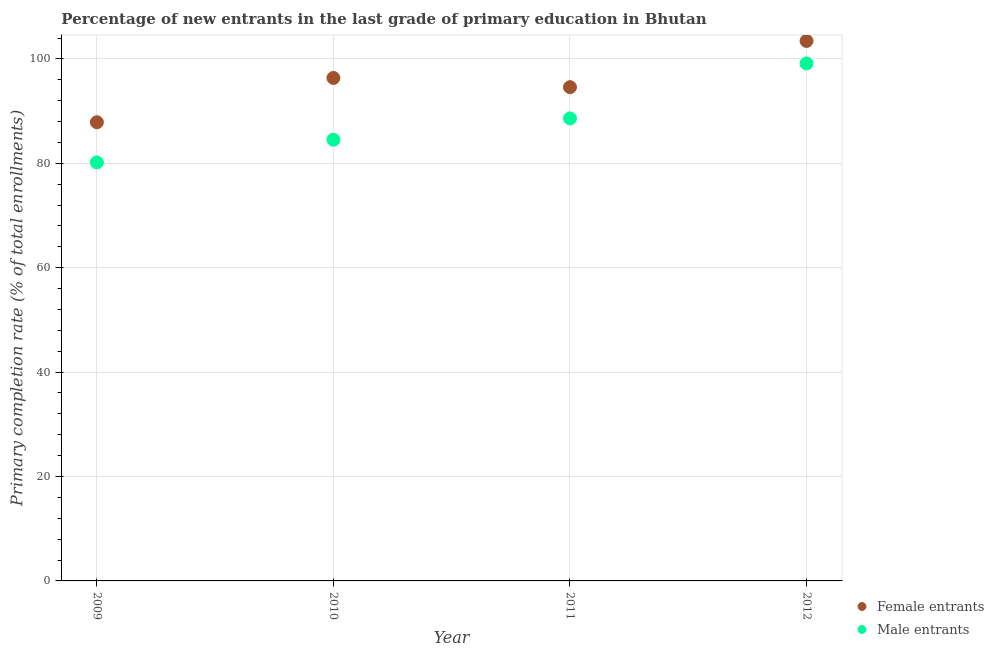How many different coloured dotlines are there?
Your response must be concise. 2. What is the primary completion rate of female entrants in 2010?
Offer a terse response. 96.35. Across all years, what is the maximum primary completion rate of female entrants?
Give a very brief answer. 103.44. Across all years, what is the minimum primary completion rate of female entrants?
Provide a succinct answer. 87.87. In which year was the primary completion rate of female entrants minimum?
Ensure brevity in your answer.  2009. What is the total primary completion rate of male entrants in the graph?
Provide a succinct answer. 352.43. What is the difference between the primary completion rate of male entrants in 2009 and that in 2011?
Ensure brevity in your answer.  -8.43. What is the difference between the primary completion rate of female entrants in 2012 and the primary completion rate of male entrants in 2009?
Offer a terse response. 23.27. What is the average primary completion rate of female entrants per year?
Your answer should be very brief. 95.56. In the year 2010, what is the difference between the primary completion rate of male entrants and primary completion rate of female entrants?
Provide a succinct answer. -11.83. What is the ratio of the primary completion rate of female entrants in 2009 to that in 2011?
Provide a succinct answer. 0.93. Is the primary completion rate of male entrants in 2010 less than that in 2012?
Make the answer very short. Yes. Is the difference between the primary completion rate of male entrants in 2010 and 2012 greater than the difference between the primary completion rate of female entrants in 2010 and 2012?
Offer a very short reply. No. What is the difference between the highest and the second highest primary completion rate of female entrants?
Offer a terse response. 7.09. What is the difference between the highest and the lowest primary completion rate of male entrants?
Offer a terse response. 18.96. In how many years, is the primary completion rate of female entrants greater than the average primary completion rate of female entrants taken over all years?
Give a very brief answer. 2. Is the sum of the primary completion rate of female entrants in 2009 and 2011 greater than the maximum primary completion rate of male entrants across all years?
Your answer should be very brief. Yes. Does the primary completion rate of female entrants monotonically increase over the years?
Keep it short and to the point. No. Is the primary completion rate of male entrants strictly greater than the primary completion rate of female entrants over the years?
Make the answer very short. No. How many dotlines are there?
Ensure brevity in your answer.  2. How many years are there in the graph?
Offer a very short reply. 4. What is the difference between two consecutive major ticks on the Y-axis?
Your answer should be very brief. 20. Where does the legend appear in the graph?
Ensure brevity in your answer.  Bottom right. What is the title of the graph?
Your answer should be very brief. Percentage of new entrants in the last grade of primary education in Bhutan. What is the label or title of the X-axis?
Keep it short and to the point. Year. What is the label or title of the Y-axis?
Your answer should be very brief. Primary completion rate (% of total enrollments). What is the Primary completion rate (% of total enrollments) of Female entrants in 2009?
Offer a terse response. 87.87. What is the Primary completion rate (% of total enrollments) in Male entrants in 2009?
Keep it short and to the point. 80.17. What is the Primary completion rate (% of total enrollments) of Female entrants in 2010?
Keep it short and to the point. 96.35. What is the Primary completion rate (% of total enrollments) of Male entrants in 2010?
Give a very brief answer. 84.52. What is the Primary completion rate (% of total enrollments) of Female entrants in 2011?
Provide a succinct answer. 94.58. What is the Primary completion rate (% of total enrollments) of Male entrants in 2011?
Your answer should be very brief. 88.61. What is the Primary completion rate (% of total enrollments) in Female entrants in 2012?
Give a very brief answer. 103.44. What is the Primary completion rate (% of total enrollments) of Male entrants in 2012?
Provide a short and direct response. 99.14. Across all years, what is the maximum Primary completion rate (% of total enrollments) in Female entrants?
Offer a terse response. 103.44. Across all years, what is the maximum Primary completion rate (% of total enrollments) of Male entrants?
Your answer should be very brief. 99.14. Across all years, what is the minimum Primary completion rate (% of total enrollments) in Female entrants?
Make the answer very short. 87.87. Across all years, what is the minimum Primary completion rate (% of total enrollments) in Male entrants?
Offer a terse response. 80.17. What is the total Primary completion rate (% of total enrollments) of Female entrants in the graph?
Offer a very short reply. 382.24. What is the total Primary completion rate (% of total enrollments) in Male entrants in the graph?
Give a very brief answer. 352.43. What is the difference between the Primary completion rate (% of total enrollments) in Female entrants in 2009 and that in 2010?
Give a very brief answer. -8.49. What is the difference between the Primary completion rate (% of total enrollments) in Male entrants in 2009 and that in 2010?
Your answer should be compact. -4.35. What is the difference between the Primary completion rate (% of total enrollments) in Female entrants in 2009 and that in 2011?
Your answer should be very brief. -6.72. What is the difference between the Primary completion rate (% of total enrollments) in Male entrants in 2009 and that in 2011?
Your answer should be very brief. -8.43. What is the difference between the Primary completion rate (% of total enrollments) in Female entrants in 2009 and that in 2012?
Provide a short and direct response. -15.58. What is the difference between the Primary completion rate (% of total enrollments) of Male entrants in 2009 and that in 2012?
Offer a very short reply. -18.96. What is the difference between the Primary completion rate (% of total enrollments) of Female entrants in 2010 and that in 2011?
Make the answer very short. 1.77. What is the difference between the Primary completion rate (% of total enrollments) of Male entrants in 2010 and that in 2011?
Provide a short and direct response. -4.09. What is the difference between the Primary completion rate (% of total enrollments) of Female entrants in 2010 and that in 2012?
Make the answer very short. -7.09. What is the difference between the Primary completion rate (% of total enrollments) of Male entrants in 2010 and that in 2012?
Your answer should be very brief. -14.62. What is the difference between the Primary completion rate (% of total enrollments) in Female entrants in 2011 and that in 2012?
Make the answer very short. -8.86. What is the difference between the Primary completion rate (% of total enrollments) in Male entrants in 2011 and that in 2012?
Ensure brevity in your answer.  -10.53. What is the difference between the Primary completion rate (% of total enrollments) in Female entrants in 2009 and the Primary completion rate (% of total enrollments) in Male entrants in 2010?
Keep it short and to the point. 3.35. What is the difference between the Primary completion rate (% of total enrollments) of Female entrants in 2009 and the Primary completion rate (% of total enrollments) of Male entrants in 2011?
Provide a short and direct response. -0.74. What is the difference between the Primary completion rate (% of total enrollments) of Female entrants in 2009 and the Primary completion rate (% of total enrollments) of Male entrants in 2012?
Your response must be concise. -11.27. What is the difference between the Primary completion rate (% of total enrollments) of Female entrants in 2010 and the Primary completion rate (% of total enrollments) of Male entrants in 2011?
Make the answer very short. 7.75. What is the difference between the Primary completion rate (% of total enrollments) in Female entrants in 2010 and the Primary completion rate (% of total enrollments) in Male entrants in 2012?
Keep it short and to the point. -2.78. What is the difference between the Primary completion rate (% of total enrollments) in Female entrants in 2011 and the Primary completion rate (% of total enrollments) in Male entrants in 2012?
Your answer should be very brief. -4.55. What is the average Primary completion rate (% of total enrollments) of Female entrants per year?
Make the answer very short. 95.56. What is the average Primary completion rate (% of total enrollments) of Male entrants per year?
Your response must be concise. 88.11. In the year 2009, what is the difference between the Primary completion rate (% of total enrollments) in Female entrants and Primary completion rate (% of total enrollments) in Male entrants?
Make the answer very short. 7.69. In the year 2010, what is the difference between the Primary completion rate (% of total enrollments) of Female entrants and Primary completion rate (% of total enrollments) of Male entrants?
Your answer should be compact. 11.83. In the year 2011, what is the difference between the Primary completion rate (% of total enrollments) in Female entrants and Primary completion rate (% of total enrollments) in Male entrants?
Keep it short and to the point. 5.98. In the year 2012, what is the difference between the Primary completion rate (% of total enrollments) of Female entrants and Primary completion rate (% of total enrollments) of Male entrants?
Your response must be concise. 4.31. What is the ratio of the Primary completion rate (% of total enrollments) of Female entrants in 2009 to that in 2010?
Provide a short and direct response. 0.91. What is the ratio of the Primary completion rate (% of total enrollments) in Male entrants in 2009 to that in 2010?
Your response must be concise. 0.95. What is the ratio of the Primary completion rate (% of total enrollments) of Female entrants in 2009 to that in 2011?
Provide a short and direct response. 0.93. What is the ratio of the Primary completion rate (% of total enrollments) of Male entrants in 2009 to that in 2011?
Provide a succinct answer. 0.9. What is the ratio of the Primary completion rate (% of total enrollments) of Female entrants in 2009 to that in 2012?
Provide a succinct answer. 0.85. What is the ratio of the Primary completion rate (% of total enrollments) in Male entrants in 2009 to that in 2012?
Keep it short and to the point. 0.81. What is the ratio of the Primary completion rate (% of total enrollments) in Female entrants in 2010 to that in 2011?
Provide a short and direct response. 1.02. What is the ratio of the Primary completion rate (% of total enrollments) of Male entrants in 2010 to that in 2011?
Provide a short and direct response. 0.95. What is the ratio of the Primary completion rate (% of total enrollments) of Female entrants in 2010 to that in 2012?
Your answer should be very brief. 0.93. What is the ratio of the Primary completion rate (% of total enrollments) in Male entrants in 2010 to that in 2012?
Offer a very short reply. 0.85. What is the ratio of the Primary completion rate (% of total enrollments) of Female entrants in 2011 to that in 2012?
Your answer should be compact. 0.91. What is the ratio of the Primary completion rate (% of total enrollments) in Male entrants in 2011 to that in 2012?
Your answer should be very brief. 0.89. What is the difference between the highest and the second highest Primary completion rate (% of total enrollments) of Female entrants?
Provide a succinct answer. 7.09. What is the difference between the highest and the second highest Primary completion rate (% of total enrollments) of Male entrants?
Keep it short and to the point. 10.53. What is the difference between the highest and the lowest Primary completion rate (% of total enrollments) in Female entrants?
Your answer should be very brief. 15.58. What is the difference between the highest and the lowest Primary completion rate (% of total enrollments) of Male entrants?
Ensure brevity in your answer.  18.96. 